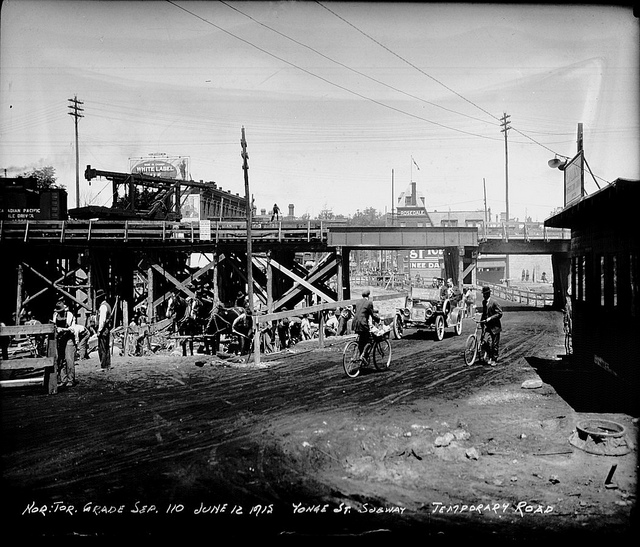Read and extract the text from this image. 110 JUNE 12 mis SEP. WHITE ROAD TEMPORARY SUBWAY YONGE GRADE TOR NOR 